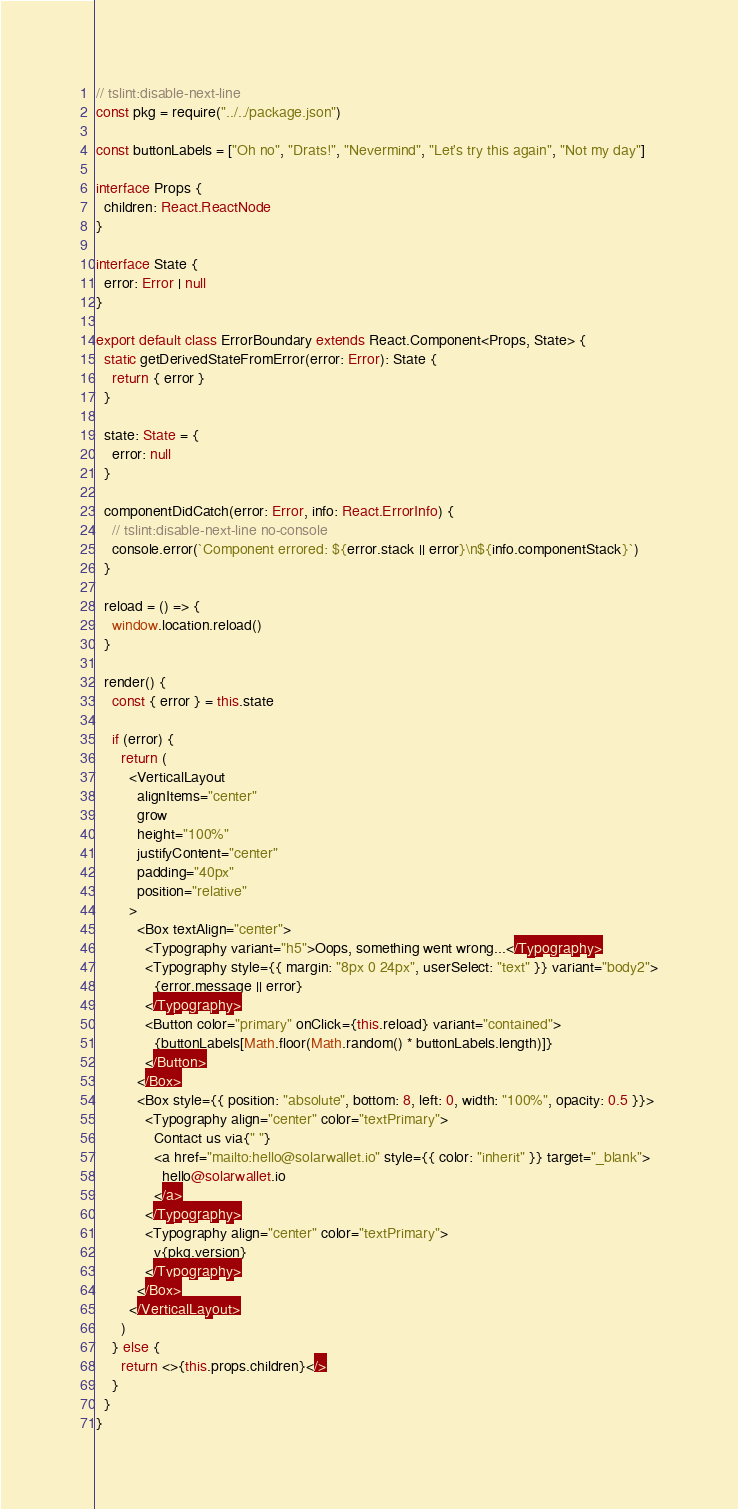Convert code to text. <code><loc_0><loc_0><loc_500><loc_500><_TypeScript_>// tslint:disable-next-line
const pkg = require("../../package.json")

const buttonLabels = ["Oh no", "Drats!", "Nevermind", "Let's try this again", "Not my day"]

interface Props {
  children: React.ReactNode
}

interface State {
  error: Error | null
}

export default class ErrorBoundary extends React.Component<Props, State> {
  static getDerivedStateFromError(error: Error): State {
    return { error }
  }

  state: State = {
    error: null
  }

  componentDidCatch(error: Error, info: React.ErrorInfo) {
    // tslint:disable-next-line no-console
    console.error(`Component errored: ${error.stack || error}\n${info.componentStack}`)
  }

  reload = () => {
    window.location.reload()
  }

  render() {
    const { error } = this.state

    if (error) {
      return (
        <VerticalLayout
          alignItems="center"
          grow
          height="100%"
          justifyContent="center"
          padding="40px"
          position="relative"
        >
          <Box textAlign="center">
            <Typography variant="h5">Oops, something went wrong...</Typography>
            <Typography style={{ margin: "8px 0 24px", userSelect: "text" }} variant="body2">
              {error.message || error}
            </Typography>
            <Button color="primary" onClick={this.reload} variant="contained">
              {buttonLabels[Math.floor(Math.random() * buttonLabels.length)]}
            </Button>
          </Box>
          <Box style={{ position: "absolute", bottom: 8, left: 0, width: "100%", opacity: 0.5 }}>
            <Typography align="center" color="textPrimary">
              Contact us via{" "}
              <a href="mailto:hello@solarwallet.io" style={{ color: "inherit" }} target="_blank">
                hello@solarwallet.io
              </a>
            </Typography>
            <Typography align="center" color="textPrimary">
              v{pkg.version}
            </Typography>
          </Box>
        </VerticalLayout>
      )
    } else {
      return <>{this.props.children}</>
    }
  }
}
</code> 